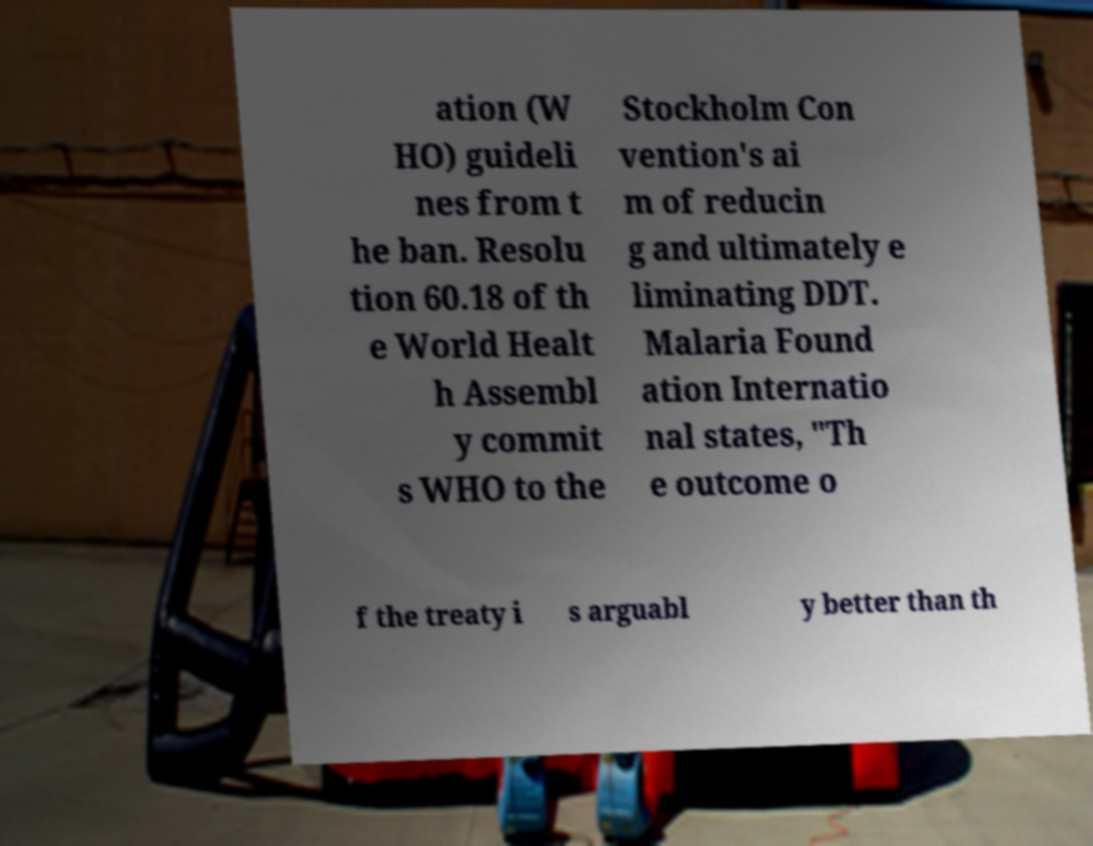Can you read and provide the text displayed in the image?This photo seems to have some interesting text. Can you extract and type it out for me? ation (W HO) guideli nes from t he ban. Resolu tion 60.18 of th e World Healt h Assembl y commit s WHO to the Stockholm Con vention's ai m of reducin g and ultimately e liminating DDT. Malaria Found ation Internatio nal states, "Th e outcome o f the treaty i s arguabl y better than th 